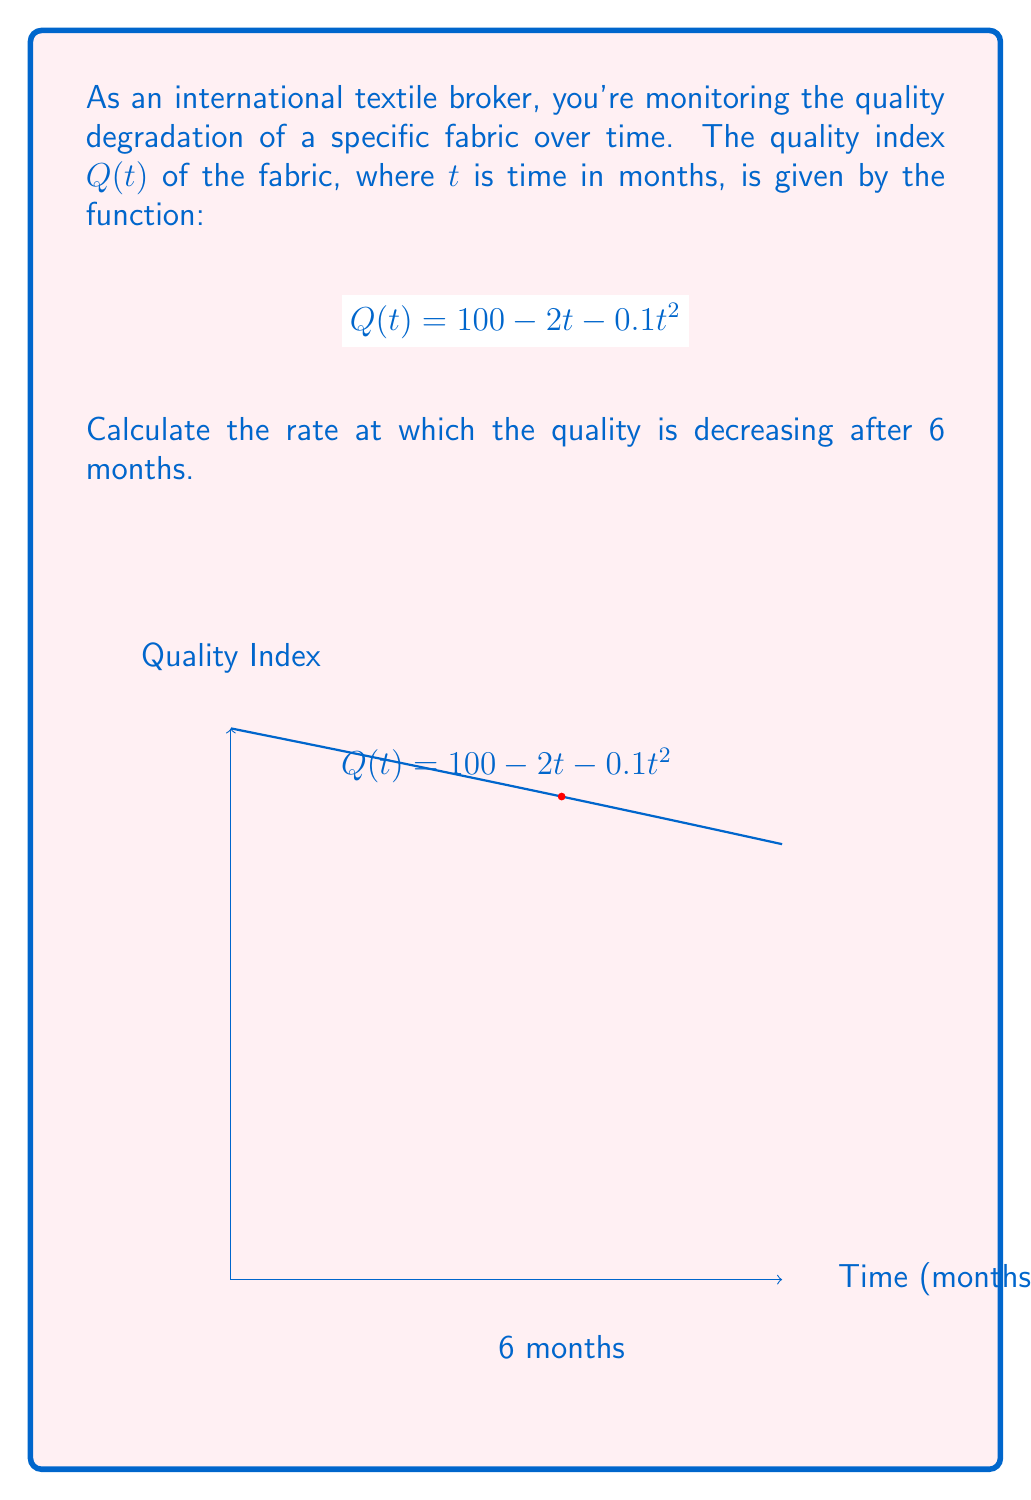Can you answer this question? To find the rate at which the quality is decreasing after 6 months, we need to calculate the derivative of $Q(t)$ and evaluate it at $t=6$. Here's the step-by-step process:

1) The given function is $Q(t) = 100 - 2t - 0.1t^2$

2) To find the rate of change, we need to differentiate $Q(t)$ with respect to $t$:
   $$\frac{dQ}{dt} = -2 - 0.2t$$

3) This derivative represents the instantaneous rate of change of quality with respect to time.

4) To find the rate of decrease after 6 months, we evaluate $\frac{dQ}{dt}$ at $t=6$:
   $$\frac{dQ}{dt}\bigg|_{t=6} = -2 - 0.2(6) = -2 - 1.2 = -3.2$$

5) The negative sign indicates that the quality is decreasing.

Therefore, after 6 months, the quality is decreasing at a rate of 3.2 units per month.
Answer: $-3.2$ units per month 